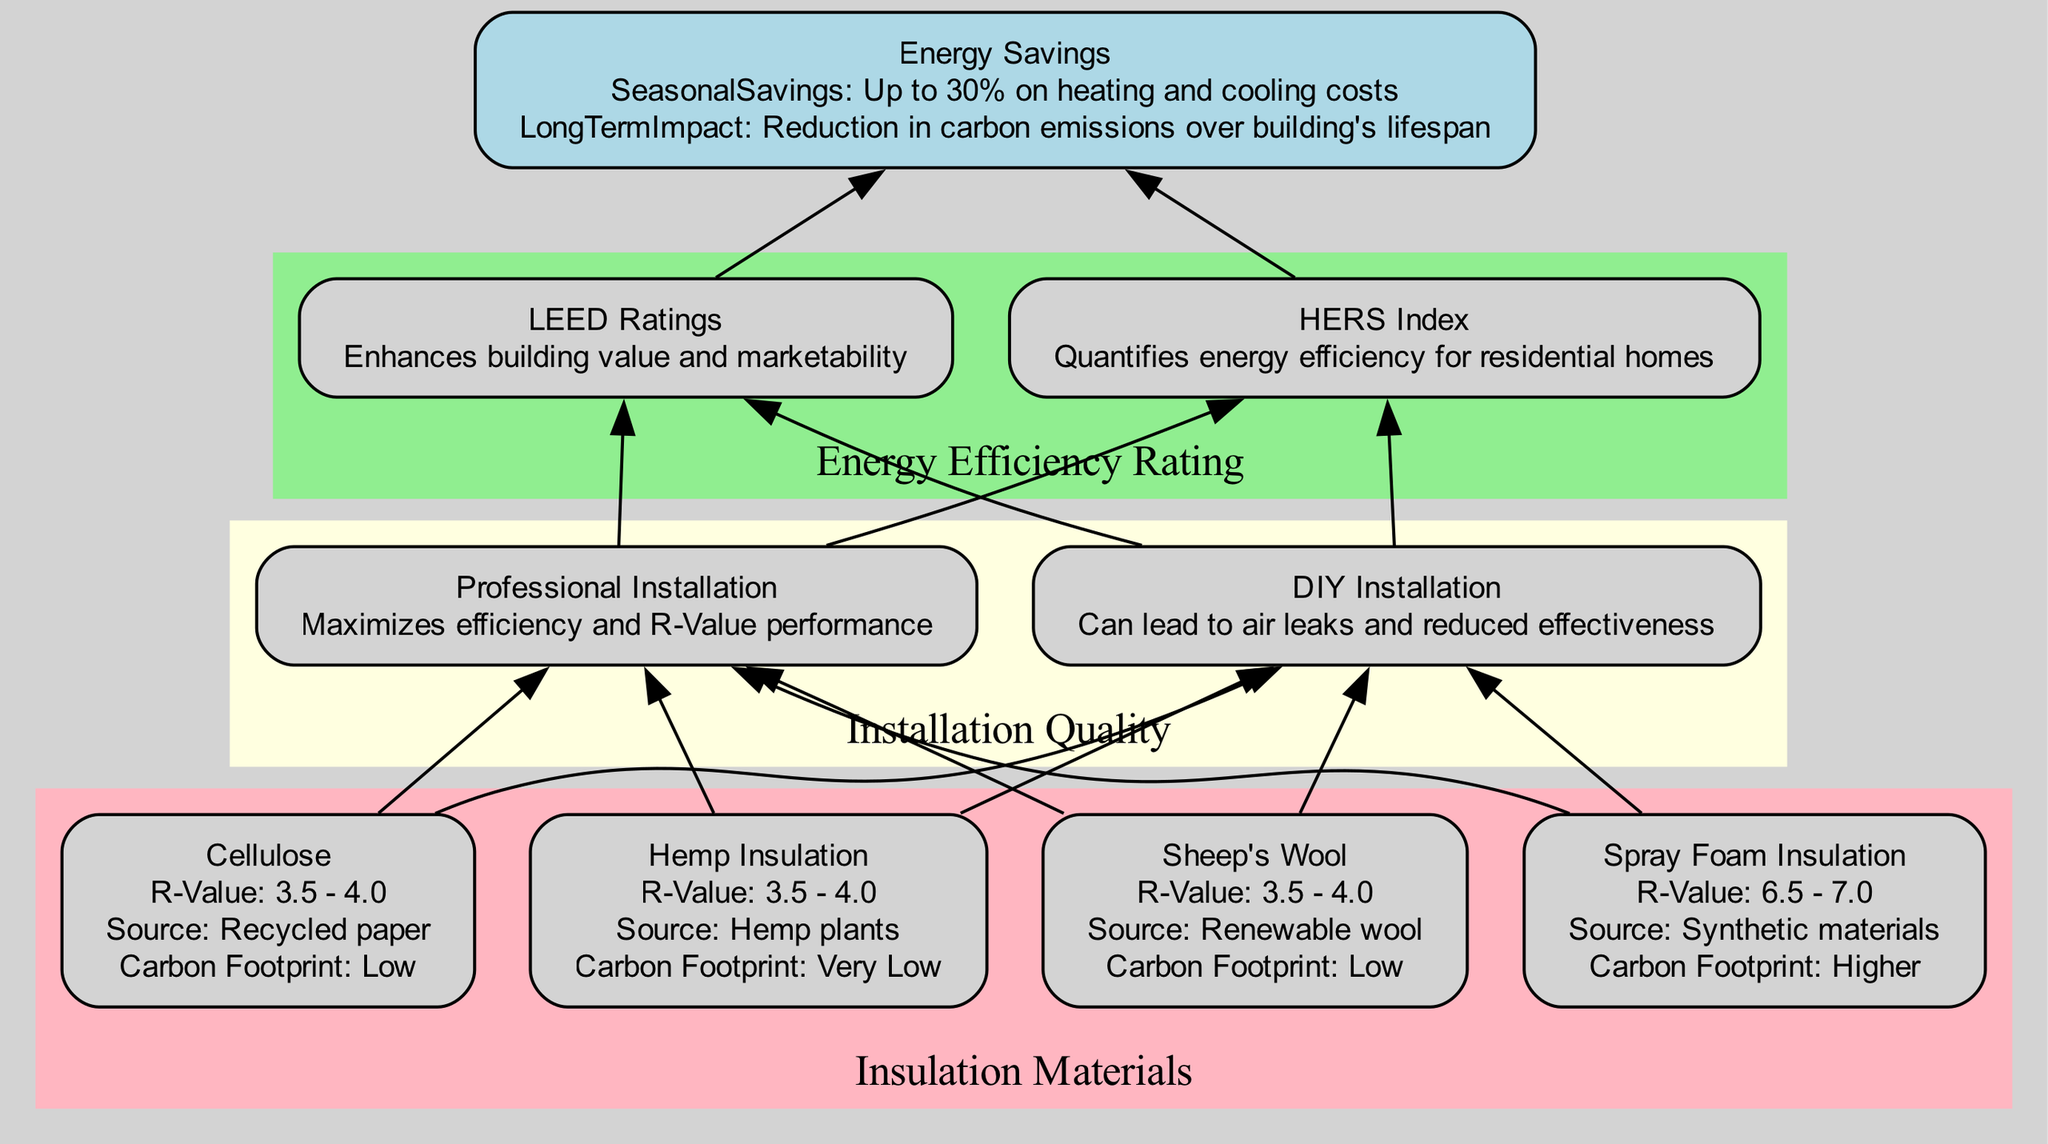What is the R-Value range for Spray Foam Insulation? The diagram lists the R-Value for Spray Foam Insulation specifically as 6.5 - 7.0. This information can be found under the Insulation Materials section, directly linked to the option for Spray Foam Insulation.
Answer: 6.5 - 7.0 How many types of Insulation Materials are presented in the diagram? The diagram includes four types of Insulation Materials: Cellulose, Hemp Insulation, Sheep's Wool, and Spray Foam Insulation. By counting the options in the Insulation Materials cluster, we see there are four distinct materials.
Answer: 4 What impact does Professional Installation have on energy efficiency? The diagram states that Professional Installation maximizes efficiency and R-Value performance. This is noted in the Installation Quality cluster, linking it to the overall effectiveness of the insulation type.
Answer: Maximizes efficiency and R-Value performance Which insulation type has the lowest carbon footprint? According to the diagram, Hemp Insulation has a "Very Low" carbon footprint. This information is explicitly described in the Insulation Materials section under the attributes of Hemp Insulation.
Answer: Very Low What energy efficiency rating enhances building value? The diagram indicates that LEED Ratings enhance building value and marketability. In the Energy Efficiency Rating cluster, this impact is specifically mentioned alongside the LEED Ratings option.
Answer: Enhances building value and marketability If a DIY installation is chosen, what is the potential risk? The diagram mentions that DIY Installation can lead to air leaks and reduced effectiveness. This effect is highlighted as a concern in the Installation Quality cluster related to self-installation practices compared to professional efforts.
Answer: Can lead to air leaks and reduced effectiveness What seasonal savings can be achieved through alternative insulation? The diagram specifies that up to 30% on heating and cooling costs can be saved seasonally with the use of alternative insulation options. This saving is described in the Energy Savings node.
Answer: Up to 30% on heating and cooling costs How do energy efficiency ratings influence energy savings? The diagram shows connections from Energy Efficiency Ratings to Energy Savings, indicating that well-rated insulation systems contribute to effective energy savings, including reduced energy consumption and potentially lower utility bills. Thus, a good rating directly enhances energy savings.
Answer: Enhances energy savings Which insulation option has a higher carbon footprint? In the diagram, Spray Foam Insulation is noted to have a "Higher" carbon footprint compared to the other listed insulation types, which are primarily low or very low in carbon impact. This information is presented in the Insulation Materials section.
Answer: Higher 